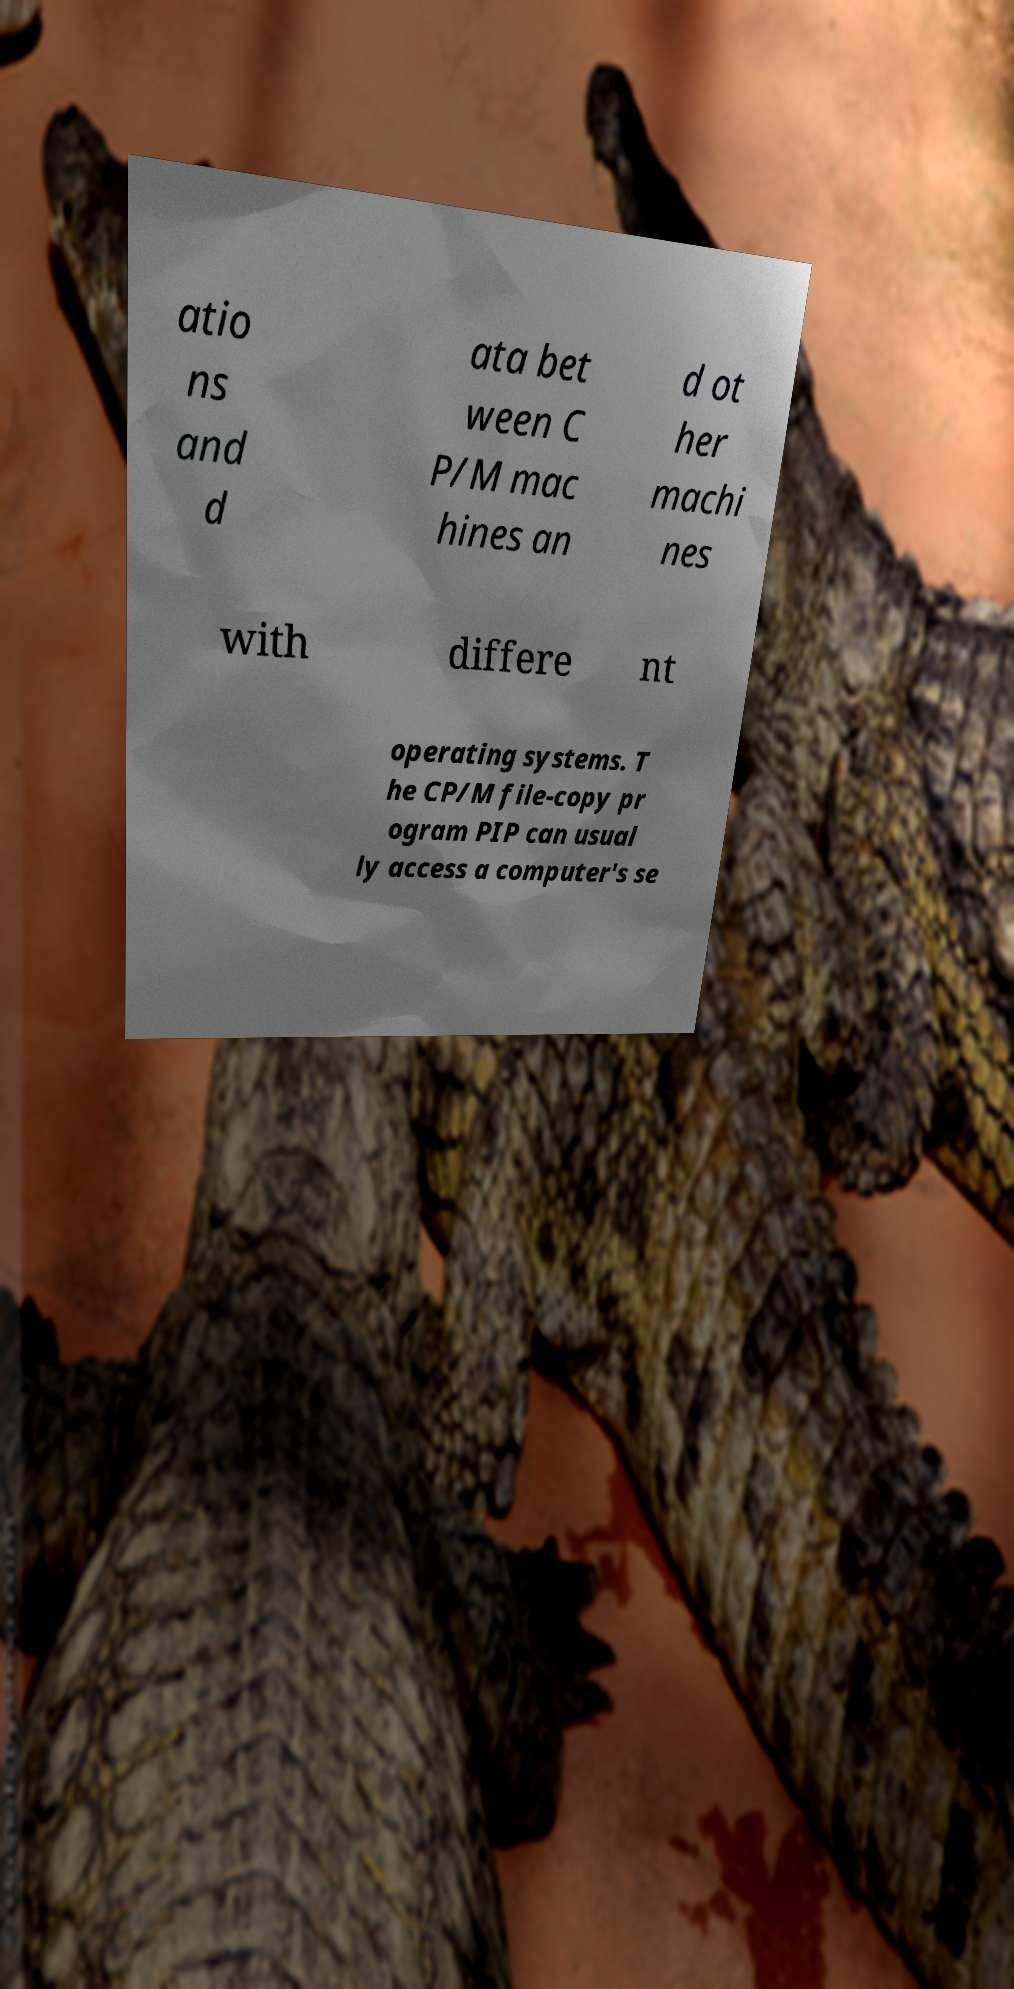For documentation purposes, I need the text within this image transcribed. Could you provide that? atio ns and d ata bet ween C P/M mac hines an d ot her machi nes with differe nt operating systems. T he CP/M file-copy pr ogram PIP can usual ly access a computer's se 